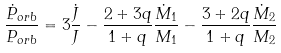Convert formula to latex. <formula><loc_0><loc_0><loc_500><loc_500>\frac { \dot { P } _ { o r b } } { P _ { o r b } } = 3 \frac { \dot { J } } { J } - \frac { 2 + 3 q } { 1 + q } \frac { \dot { M } _ { 1 } } { M _ { 1 } } - \frac { 3 + 2 q } { 1 + q } \frac { \dot { M } _ { 2 } } { M _ { 2 } }</formula> 